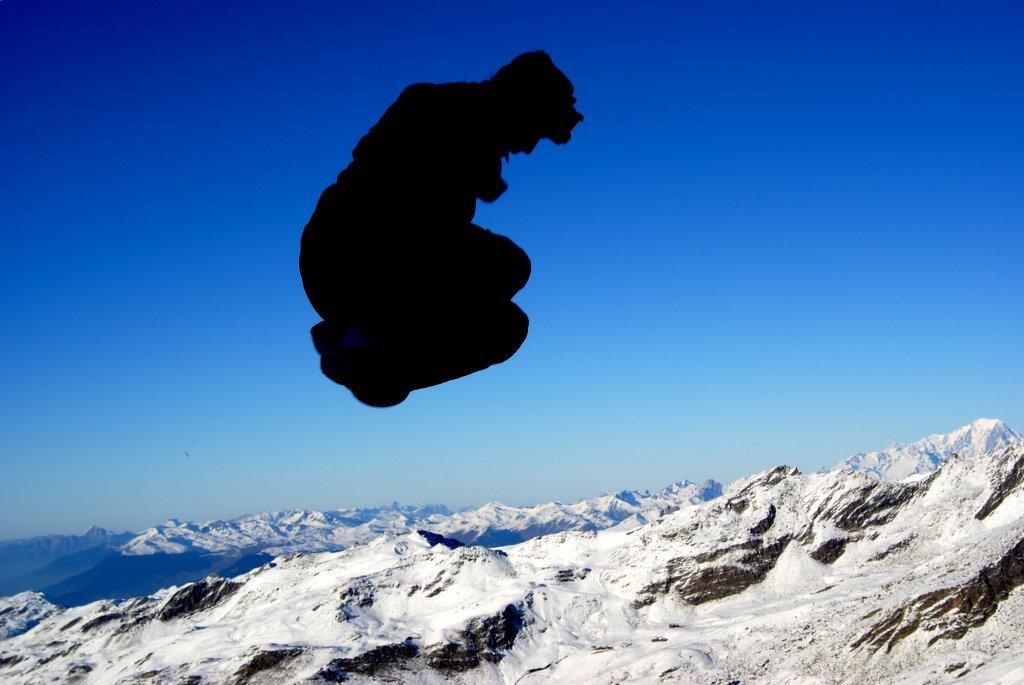What is happening to the person in the image? The person is in the air in the image. What can be seen in the background of the image? There are snow mountains and the sky visible in the background of the image. What type of rifle is the person holding in the image? There is no rifle present in the image; the person is simply in the air. 